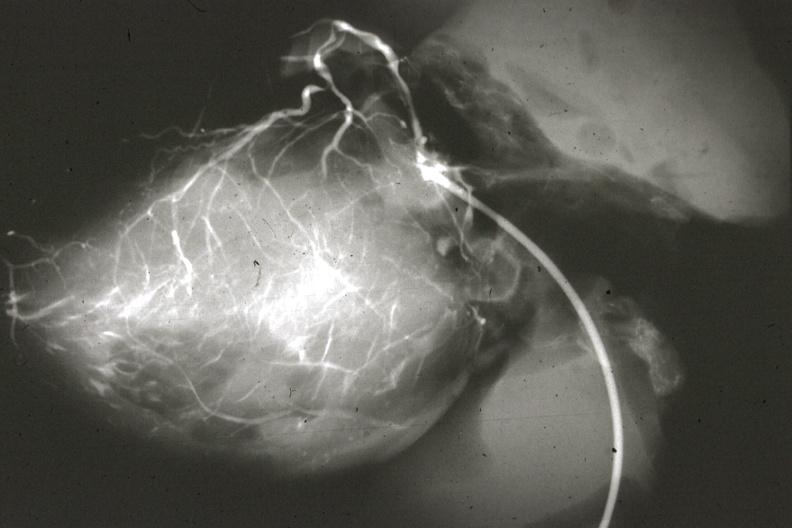how is anomalous origin left from artery?
Answer the question using a single word or phrase. Pulmonary 